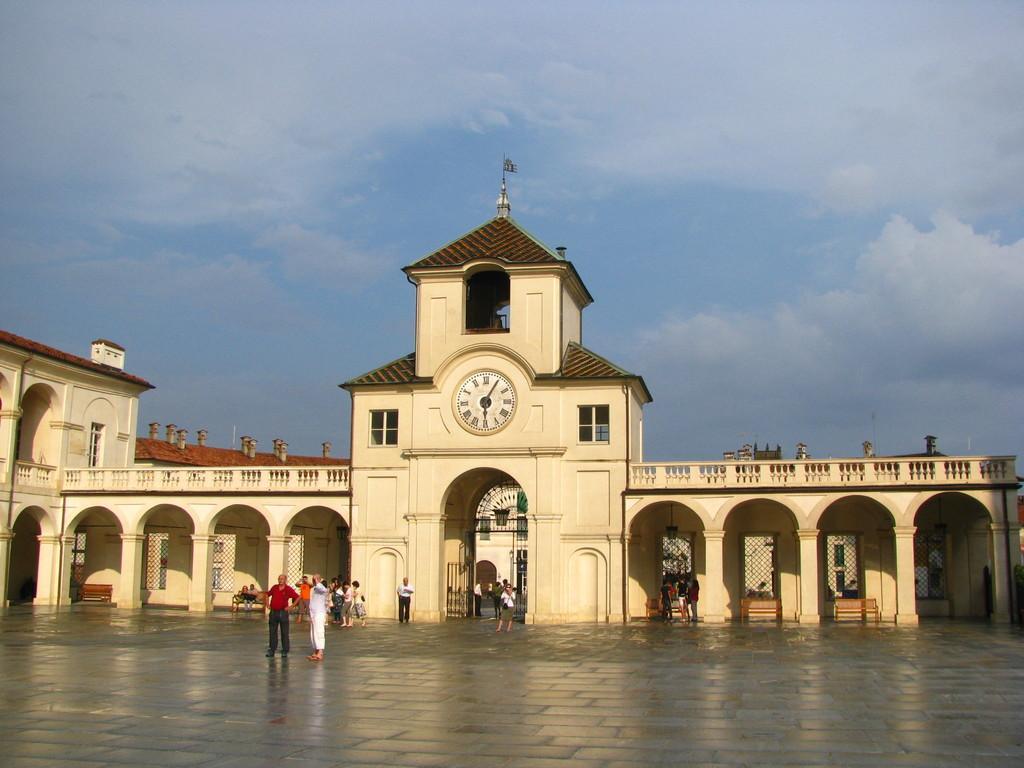Please provide a concise description of this image. In this image we can see a building, people, chairs and other objects. At the bottom of the image there is the floor. At the top of the image there is the sky. 